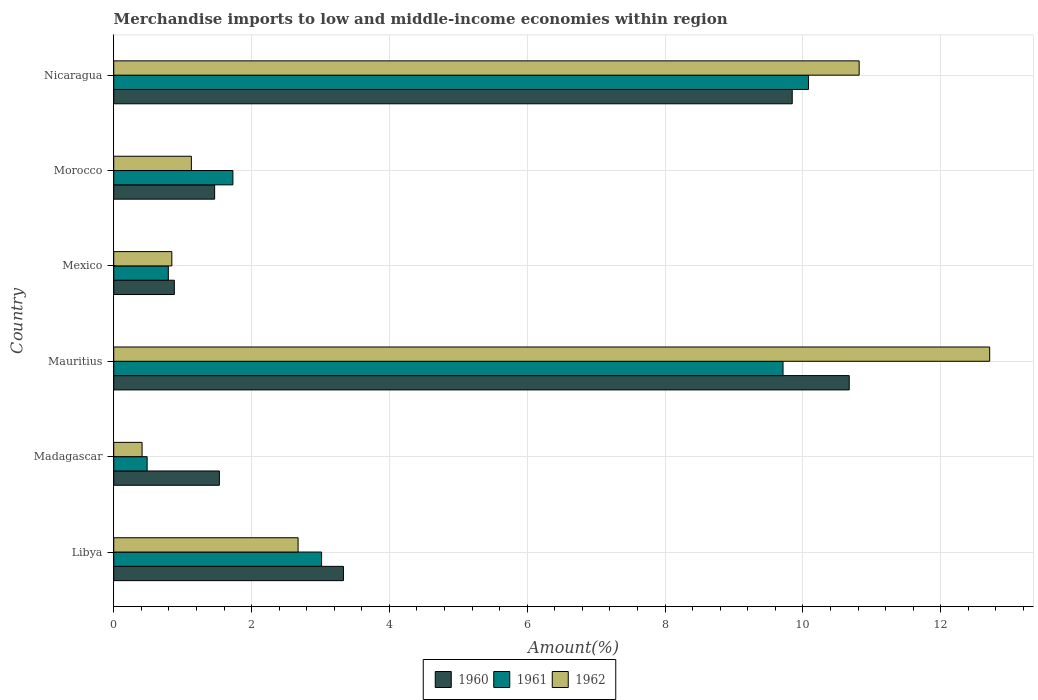How many different coloured bars are there?
Keep it short and to the point. 3. How many groups of bars are there?
Provide a succinct answer. 6. Are the number of bars per tick equal to the number of legend labels?
Provide a short and direct response. Yes. How many bars are there on the 5th tick from the bottom?
Offer a very short reply. 3. In how many cases, is the number of bars for a given country not equal to the number of legend labels?
Your response must be concise. 0. What is the percentage of amount earned from merchandise imports in 1961 in Libya?
Offer a very short reply. 3.02. Across all countries, what is the maximum percentage of amount earned from merchandise imports in 1960?
Provide a short and direct response. 10.67. Across all countries, what is the minimum percentage of amount earned from merchandise imports in 1961?
Ensure brevity in your answer.  0.48. In which country was the percentage of amount earned from merchandise imports in 1961 maximum?
Your answer should be very brief. Nicaragua. In which country was the percentage of amount earned from merchandise imports in 1961 minimum?
Make the answer very short. Madagascar. What is the total percentage of amount earned from merchandise imports in 1962 in the graph?
Your answer should be compact. 28.58. What is the difference between the percentage of amount earned from merchandise imports in 1960 in Mexico and that in Morocco?
Your answer should be compact. -0.59. What is the difference between the percentage of amount earned from merchandise imports in 1960 in Mauritius and the percentage of amount earned from merchandise imports in 1962 in Libya?
Keep it short and to the point. 8. What is the average percentage of amount earned from merchandise imports in 1961 per country?
Provide a succinct answer. 4.3. What is the difference between the percentage of amount earned from merchandise imports in 1960 and percentage of amount earned from merchandise imports in 1962 in Mauritius?
Provide a succinct answer. -2.04. What is the ratio of the percentage of amount earned from merchandise imports in 1960 in Mauritius to that in Morocco?
Ensure brevity in your answer.  7.29. Is the percentage of amount earned from merchandise imports in 1961 in Madagascar less than that in Mauritius?
Provide a succinct answer. Yes. What is the difference between the highest and the second highest percentage of amount earned from merchandise imports in 1962?
Provide a succinct answer. 1.89. What is the difference between the highest and the lowest percentage of amount earned from merchandise imports in 1962?
Offer a very short reply. 12.3. In how many countries, is the percentage of amount earned from merchandise imports in 1962 greater than the average percentage of amount earned from merchandise imports in 1962 taken over all countries?
Keep it short and to the point. 2. What does the 1st bar from the top in Mexico represents?
Keep it short and to the point. 1962. Are all the bars in the graph horizontal?
Ensure brevity in your answer.  Yes. How many countries are there in the graph?
Provide a short and direct response. 6. What is the difference between two consecutive major ticks on the X-axis?
Make the answer very short. 2. Are the values on the major ticks of X-axis written in scientific E-notation?
Your answer should be very brief. No. Does the graph contain any zero values?
Your answer should be very brief. No. Where does the legend appear in the graph?
Your answer should be very brief. Bottom center. How many legend labels are there?
Your answer should be compact. 3. How are the legend labels stacked?
Provide a short and direct response. Horizontal. What is the title of the graph?
Ensure brevity in your answer.  Merchandise imports to low and middle-income economies within region. Does "1970" appear as one of the legend labels in the graph?
Provide a succinct answer. No. What is the label or title of the X-axis?
Your response must be concise. Amount(%). What is the Amount(%) in 1960 in Libya?
Offer a terse response. 3.33. What is the Amount(%) of 1961 in Libya?
Provide a succinct answer. 3.02. What is the Amount(%) of 1962 in Libya?
Your answer should be compact. 2.68. What is the Amount(%) of 1960 in Madagascar?
Ensure brevity in your answer.  1.53. What is the Amount(%) in 1961 in Madagascar?
Your response must be concise. 0.48. What is the Amount(%) of 1962 in Madagascar?
Ensure brevity in your answer.  0.41. What is the Amount(%) of 1960 in Mauritius?
Offer a terse response. 10.67. What is the Amount(%) in 1961 in Mauritius?
Ensure brevity in your answer.  9.71. What is the Amount(%) of 1962 in Mauritius?
Ensure brevity in your answer.  12.71. What is the Amount(%) in 1960 in Mexico?
Provide a short and direct response. 0.88. What is the Amount(%) of 1961 in Mexico?
Offer a terse response. 0.79. What is the Amount(%) in 1962 in Mexico?
Offer a terse response. 0.84. What is the Amount(%) in 1960 in Morocco?
Your answer should be very brief. 1.46. What is the Amount(%) of 1961 in Morocco?
Your answer should be compact. 1.73. What is the Amount(%) in 1962 in Morocco?
Offer a terse response. 1.13. What is the Amount(%) of 1960 in Nicaragua?
Ensure brevity in your answer.  9.85. What is the Amount(%) in 1961 in Nicaragua?
Provide a short and direct response. 10.08. What is the Amount(%) of 1962 in Nicaragua?
Your response must be concise. 10.82. Across all countries, what is the maximum Amount(%) in 1960?
Provide a short and direct response. 10.67. Across all countries, what is the maximum Amount(%) in 1961?
Your response must be concise. 10.08. Across all countries, what is the maximum Amount(%) of 1962?
Ensure brevity in your answer.  12.71. Across all countries, what is the minimum Amount(%) in 1960?
Offer a very short reply. 0.88. Across all countries, what is the minimum Amount(%) in 1961?
Give a very brief answer. 0.48. Across all countries, what is the minimum Amount(%) in 1962?
Make the answer very short. 0.41. What is the total Amount(%) in 1960 in the graph?
Offer a very short reply. 27.73. What is the total Amount(%) of 1961 in the graph?
Keep it short and to the point. 25.81. What is the total Amount(%) of 1962 in the graph?
Keep it short and to the point. 28.58. What is the difference between the Amount(%) of 1960 in Libya and that in Madagascar?
Offer a very short reply. 1.8. What is the difference between the Amount(%) in 1961 in Libya and that in Madagascar?
Your answer should be very brief. 2.53. What is the difference between the Amount(%) in 1962 in Libya and that in Madagascar?
Provide a succinct answer. 2.26. What is the difference between the Amount(%) in 1960 in Libya and that in Mauritius?
Give a very brief answer. -7.34. What is the difference between the Amount(%) in 1961 in Libya and that in Mauritius?
Your answer should be very brief. -6.7. What is the difference between the Amount(%) in 1962 in Libya and that in Mauritius?
Give a very brief answer. -10.04. What is the difference between the Amount(%) in 1960 in Libya and that in Mexico?
Offer a very short reply. 2.45. What is the difference between the Amount(%) in 1961 in Libya and that in Mexico?
Offer a very short reply. 2.22. What is the difference between the Amount(%) of 1962 in Libya and that in Mexico?
Ensure brevity in your answer.  1.83. What is the difference between the Amount(%) in 1960 in Libya and that in Morocco?
Keep it short and to the point. 1.87. What is the difference between the Amount(%) in 1961 in Libya and that in Morocco?
Offer a very short reply. 1.29. What is the difference between the Amount(%) in 1962 in Libya and that in Morocco?
Keep it short and to the point. 1.55. What is the difference between the Amount(%) of 1960 in Libya and that in Nicaragua?
Provide a succinct answer. -6.51. What is the difference between the Amount(%) in 1961 in Libya and that in Nicaragua?
Ensure brevity in your answer.  -7.06. What is the difference between the Amount(%) of 1962 in Libya and that in Nicaragua?
Make the answer very short. -8.14. What is the difference between the Amount(%) of 1960 in Madagascar and that in Mauritius?
Your response must be concise. -9.14. What is the difference between the Amount(%) of 1961 in Madagascar and that in Mauritius?
Your answer should be very brief. -9.23. What is the difference between the Amount(%) in 1962 in Madagascar and that in Mauritius?
Provide a short and direct response. -12.3. What is the difference between the Amount(%) in 1960 in Madagascar and that in Mexico?
Provide a short and direct response. 0.65. What is the difference between the Amount(%) of 1961 in Madagascar and that in Mexico?
Ensure brevity in your answer.  -0.31. What is the difference between the Amount(%) of 1962 in Madagascar and that in Mexico?
Your response must be concise. -0.43. What is the difference between the Amount(%) of 1960 in Madagascar and that in Morocco?
Your response must be concise. 0.07. What is the difference between the Amount(%) of 1961 in Madagascar and that in Morocco?
Your response must be concise. -1.24. What is the difference between the Amount(%) in 1962 in Madagascar and that in Morocco?
Provide a succinct answer. -0.72. What is the difference between the Amount(%) in 1960 in Madagascar and that in Nicaragua?
Give a very brief answer. -8.31. What is the difference between the Amount(%) of 1961 in Madagascar and that in Nicaragua?
Your answer should be compact. -9.6. What is the difference between the Amount(%) of 1962 in Madagascar and that in Nicaragua?
Keep it short and to the point. -10.41. What is the difference between the Amount(%) of 1960 in Mauritius and that in Mexico?
Offer a terse response. 9.79. What is the difference between the Amount(%) of 1961 in Mauritius and that in Mexico?
Ensure brevity in your answer.  8.92. What is the difference between the Amount(%) in 1962 in Mauritius and that in Mexico?
Give a very brief answer. 11.87. What is the difference between the Amount(%) of 1960 in Mauritius and that in Morocco?
Offer a very short reply. 9.21. What is the difference between the Amount(%) of 1961 in Mauritius and that in Morocco?
Keep it short and to the point. 7.98. What is the difference between the Amount(%) in 1962 in Mauritius and that in Morocco?
Provide a short and direct response. 11.58. What is the difference between the Amount(%) of 1960 in Mauritius and that in Nicaragua?
Offer a terse response. 0.83. What is the difference between the Amount(%) in 1961 in Mauritius and that in Nicaragua?
Provide a succinct answer. -0.37. What is the difference between the Amount(%) in 1962 in Mauritius and that in Nicaragua?
Your answer should be very brief. 1.89. What is the difference between the Amount(%) in 1960 in Mexico and that in Morocco?
Keep it short and to the point. -0.59. What is the difference between the Amount(%) in 1961 in Mexico and that in Morocco?
Offer a terse response. -0.94. What is the difference between the Amount(%) of 1962 in Mexico and that in Morocco?
Make the answer very short. -0.28. What is the difference between the Amount(%) of 1960 in Mexico and that in Nicaragua?
Offer a terse response. -8.97. What is the difference between the Amount(%) in 1961 in Mexico and that in Nicaragua?
Your answer should be compact. -9.29. What is the difference between the Amount(%) of 1962 in Mexico and that in Nicaragua?
Provide a succinct answer. -9.97. What is the difference between the Amount(%) of 1960 in Morocco and that in Nicaragua?
Your answer should be compact. -8.38. What is the difference between the Amount(%) in 1961 in Morocco and that in Nicaragua?
Offer a terse response. -8.35. What is the difference between the Amount(%) in 1962 in Morocco and that in Nicaragua?
Provide a succinct answer. -9.69. What is the difference between the Amount(%) in 1960 in Libya and the Amount(%) in 1961 in Madagascar?
Make the answer very short. 2.85. What is the difference between the Amount(%) of 1960 in Libya and the Amount(%) of 1962 in Madagascar?
Offer a very short reply. 2.92. What is the difference between the Amount(%) in 1961 in Libya and the Amount(%) in 1962 in Madagascar?
Your response must be concise. 2.6. What is the difference between the Amount(%) of 1960 in Libya and the Amount(%) of 1961 in Mauritius?
Ensure brevity in your answer.  -6.38. What is the difference between the Amount(%) in 1960 in Libya and the Amount(%) in 1962 in Mauritius?
Provide a succinct answer. -9.38. What is the difference between the Amount(%) in 1961 in Libya and the Amount(%) in 1962 in Mauritius?
Keep it short and to the point. -9.69. What is the difference between the Amount(%) of 1960 in Libya and the Amount(%) of 1961 in Mexico?
Keep it short and to the point. 2.54. What is the difference between the Amount(%) of 1960 in Libya and the Amount(%) of 1962 in Mexico?
Your answer should be very brief. 2.49. What is the difference between the Amount(%) in 1961 in Libya and the Amount(%) in 1962 in Mexico?
Your answer should be compact. 2.17. What is the difference between the Amount(%) of 1960 in Libya and the Amount(%) of 1961 in Morocco?
Give a very brief answer. 1.6. What is the difference between the Amount(%) of 1960 in Libya and the Amount(%) of 1962 in Morocco?
Your answer should be very brief. 2.21. What is the difference between the Amount(%) in 1961 in Libya and the Amount(%) in 1962 in Morocco?
Offer a very short reply. 1.89. What is the difference between the Amount(%) of 1960 in Libya and the Amount(%) of 1961 in Nicaragua?
Provide a succinct answer. -6.75. What is the difference between the Amount(%) in 1960 in Libya and the Amount(%) in 1962 in Nicaragua?
Offer a very short reply. -7.48. What is the difference between the Amount(%) of 1961 in Libya and the Amount(%) of 1962 in Nicaragua?
Give a very brief answer. -7.8. What is the difference between the Amount(%) of 1960 in Madagascar and the Amount(%) of 1961 in Mauritius?
Your answer should be very brief. -8.18. What is the difference between the Amount(%) in 1960 in Madagascar and the Amount(%) in 1962 in Mauritius?
Keep it short and to the point. -11.18. What is the difference between the Amount(%) of 1961 in Madagascar and the Amount(%) of 1962 in Mauritius?
Your answer should be compact. -12.23. What is the difference between the Amount(%) of 1960 in Madagascar and the Amount(%) of 1961 in Mexico?
Offer a very short reply. 0.74. What is the difference between the Amount(%) of 1960 in Madagascar and the Amount(%) of 1962 in Mexico?
Offer a terse response. 0.69. What is the difference between the Amount(%) of 1961 in Madagascar and the Amount(%) of 1962 in Mexico?
Offer a terse response. -0.36. What is the difference between the Amount(%) of 1960 in Madagascar and the Amount(%) of 1961 in Morocco?
Provide a short and direct response. -0.2. What is the difference between the Amount(%) of 1960 in Madagascar and the Amount(%) of 1962 in Morocco?
Provide a short and direct response. 0.41. What is the difference between the Amount(%) of 1961 in Madagascar and the Amount(%) of 1962 in Morocco?
Make the answer very short. -0.64. What is the difference between the Amount(%) in 1960 in Madagascar and the Amount(%) in 1961 in Nicaragua?
Keep it short and to the point. -8.55. What is the difference between the Amount(%) of 1960 in Madagascar and the Amount(%) of 1962 in Nicaragua?
Your answer should be very brief. -9.28. What is the difference between the Amount(%) of 1961 in Madagascar and the Amount(%) of 1962 in Nicaragua?
Keep it short and to the point. -10.33. What is the difference between the Amount(%) of 1960 in Mauritius and the Amount(%) of 1961 in Mexico?
Your answer should be compact. 9.88. What is the difference between the Amount(%) of 1960 in Mauritius and the Amount(%) of 1962 in Mexico?
Ensure brevity in your answer.  9.83. What is the difference between the Amount(%) of 1961 in Mauritius and the Amount(%) of 1962 in Mexico?
Provide a succinct answer. 8.87. What is the difference between the Amount(%) in 1960 in Mauritius and the Amount(%) in 1961 in Morocco?
Your answer should be compact. 8.94. What is the difference between the Amount(%) in 1960 in Mauritius and the Amount(%) in 1962 in Morocco?
Provide a short and direct response. 9.55. What is the difference between the Amount(%) of 1961 in Mauritius and the Amount(%) of 1962 in Morocco?
Your response must be concise. 8.59. What is the difference between the Amount(%) of 1960 in Mauritius and the Amount(%) of 1961 in Nicaragua?
Give a very brief answer. 0.59. What is the difference between the Amount(%) of 1960 in Mauritius and the Amount(%) of 1962 in Nicaragua?
Give a very brief answer. -0.14. What is the difference between the Amount(%) in 1961 in Mauritius and the Amount(%) in 1962 in Nicaragua?
Offer a very short reply. -1.1. What is the difference between the Amount(%) of 1960 in Mexico and the Amount(%) of 1961 in Morocco?
Your answer should be compact. -0.85. What is the difference between the Amount(%) in 1960 in Mexico and the Amount(%) in 1962 in Morocco?
Your answer should be very brief. -0.25. What is the difference between the Amount(%) in 1961 in Mexico and the Amount(%) in 1962 in Morocco?
Your response must be concise. -0.33. What is the difference between the Amount(%) in 1960 in Mexico and the Amount(%) in 1961 in Nicaragua?
Offer a very short reply. -9.2. What is the difference between the Amount(%) of 1960 in Mexico and the Amount(%) of 1962 in Nicaragua?
Give a very brief answer. -9.94. What is the difference between the Amount(%) of 1961 in Mexico and the Amount(%) of 1962 in Nicaragua?
Ensure brevity in your answer.  -10.02. What is the difference between the Amount(%) in 1960 in Morocco and the Amount(%) in 1961 in Nicaragua?
Keep it short and to the point. -8.62. What is the difference between the Amount(%) of 1960 in Morocco and the Amount(%) of 1962 in Nicaragua?
Offer a very short reply. -9.35. What is the difference between the Amount(%) in 1961 in Morocco and the Amount(%) in 1962 in Nicaragua?
Provide a succinct answer. -9.09. What is the average Amount(%) of 1960 per country?
Offer a terse response. 4.62. What is the average Amount(%) in 1961 per country?
Your response must be concise. 4.3. What is the average Amount(%) of 1962 per country?
Give a very brief answer. 4.76. What is the difference between the Amount(%) in 1960 and Amount(%) in 1961 in Libya?
Provide a short and direct response. 0.32. What is the difference between the Amount(%) of 1960 and Amount(%) of 1962 in Libya?
Keep it short and to the point. 0.66. What is the difference between the Amount(%) of 1961 and Amount(%) of 1962 in Libya?
Your response must be concise. 0.34. What is the difference between the Amount(%) in 1960 and Amount(%) in 1961 in Madagascar?
Make the answer very short. 1.05. What is the difference between the Amount(%) of 1960 and Amount(%) of 1962 in Madagascar?
Provide a short and direct response. 1.12. What is the difference between the Amount(%) in 1961 and Amount(%) in 1962 in Madagascar?
Your answer should be compact. 0.07. What is the difference between the Amount(%) in 1960 and Amount(%) in 1961 in Mauritius?
Ensure brevity in your answer.  0.96. What is the difference between the Amount(%) in 1960 and Amount(%) in 1962 in Mauritius?
Keep it short and to the point. -2.04. What is the difference between the Amount(%) in 1961 and Amount(%) in 1962 in Mauritius?
Your answer should be very brief. -3. What is the difference between the Amount(%) of 1960 and Amount(%) of 1961 in Mexico?
Give a very brief answer. 0.09. What is the difference between the Amount(%) of 1960 and Amount(%) of 1962 in Mexico?
Keep it short and to the point. 0.04. What is the difference between the Amount(%) in 1961 and Amount(%) in 1962 in Mexico?
Keep it short and to the point. -0.05. What is the difference between the Amount(%) of 1960 and Amount(%) of 1961 in Morocco?
Your response must be concise. -0.27. What is the difference between the Amount(%) in 1960 and Amount(%) in 1962 in Morocco?
Your answer should be very brief. 0.34. What is the difference between the Amount(%) in 1961 and Amount(%) in 1962 in Morocco?
Your answer should be very brief. 0.6. What is the difference between the Amount(%) in 1960 and Amount(%) in 1961 in Nicaragua?
Give a very brief answer. -0.24. What is the difference between the Amount(%) of 1960 and Amount(%) of 1962 in Nicaragua?
Your answer should be compact. -0.97. What is the difference between the Amount(%) in 1961 and Amount(%) in 1962 in Nicaragua?
Ensure brevity in your answer.  -0.74. What is the ratio of the Amount(%) in 1960 in Libya to that in Madagascar?
Provide a succinct answer. 2.17. What is the ratio of the Amount(%) in 1961 in Libya to that in Madagascar?
Your answer should be compact. 6.23. What is the ratio of the Amount(%) in 1962 in Libya to that in Madagascar?
Your answer should be compact. 6.51. What is the ratio of the Amount(%) in 1960 in Libya to that in Mauritius?
Provide a succinct answer. 0.31. What is the ratio of the Amount(%) of 1961 in Libya to that in Mauritius?
Provide a short and direct response. 0.31. What is the ratio of the Amount(%) of 1962 in Libya to that in Mauritius?
Offer a very short reply. 0.21. What is the ratio of the Amount(%) of 1960 in Libya to that in Mexico?
Make the answer very short. 3.79. What is the ratio of the Amount(%) of 1961 in Libya to that in Mexico?
Your answer should be very brief. 3.81. What is the ratio of the Amount(%) in 1962 in Libya to that in Mexico?
Ensure brevity in your answer.  3.17. What is the ratio of the Amount(%) in 1960 in Libya to that in Morocco?
Your answer should be very brief. 2.28. What is the ratio of the Amount(%) of 1961 in Libya to that in Morocco?
Your response must be concise. 1.74. What is the ratio of the Amount(%) in 1962 in Libya to that in Morocco?
Give a very brief answer. 2.37. What is the ratio of the Amount(%) of 1960 in Libya to that in Nicaragua?
Your answer should be very brief. 0.34. What is the ratio of the Amount(%) in 1961 in Libya to that in Nicaragua?
Make the answer very short. 0.3. What is the ratio of the Amount(%) in 1962 in Libya to that in Nicaragua?
Keep it short and to the point. 0.25. What is the ratio of the Amount(%) in 1960 in Madagascar to that in Mauritius?
Give a very brief answer. 0.14. What is the ratio of the Amount(%) of 1961 in Madagascar to that in Mauritius?
Provide a succinct answer. 0.05. What is the ratio of the Amount(%) in 1962 in Madagascar to that in Mauritius?
Your answer should be compact. 0.03. What is the ratio of the Amount(%) of 1960 in Madagascar to that in Mexico?
Your answer should be compact. 1.74. What is the ratio of the Amount(%) in 1961 in Madagascar to that in Mexico?
Provide a short and direct response. 0.61. What is the ratio of the Amount(%) of 1962 in Madagascar to that in Mexico?
Offer a very short reply. 0.49. What is the ratio of the Amount(%) of 1960 in Madagascar to that in Morocco?
Offer a very short reply. 1.05. What is the ratio of the Amount(%) of 1961 in Madagascar to that in Morocco?
Offer a terse response. 0.28. What is the ratio of the Amount(%) of 1962 in Madagascar to that in Morocco?
Offer a very short reply. 0.36. What is the ratio of the Amount(%) of 1960 in Madagascar to that in Nicaragua?
Offer a very short reply. 0.16. What is the ratio of the Amount(%) in 1961 in Madagascar to that in Nicaragua?
Your response must be concise. 0.05. What is the ratio of the Amount(%) in 1962 in Madagascar to that in Nicaragua?
Give a very brief answer. 0.04. What is the ratio of the Amount(%) in 1960 in Mauritius to that in Mexico?
Give a very brief answer. 12.14. What is the ratio of the Amount(%) of 1961 in Mauritius to that in Mexico?
Ensure brevity in your answer.  12.26. What is the ratio of the Amount(%) of 1962 in Mauritius to that in Mexico?
Offer a very short reply. 15.08. What is the ratio of the Amount(%) of 1960 in Mauritius to that in Morocco?
Provide a succinct answer. 7.29. What is the ratio of the Amount(%) in 1961 in Mauritius to that in Morocco?
Your response must be concise. 5.62. What is the ratio of the Amount(%) of 1962 in Mauritius to that in Morocco?
Keep it short and to the point. 11.28. What is the ratio of the Amount(%) in 1960 in Mauritius to that in Nicaragua?
Keep it short and to the point. 1.08. What is the ratio of the Amount(%) in 1961 in Mauritius to that in Nicaragua?
Provide a short and direct response. 0.96. What is the ratio of the Amount(%) in 1962 in Mauritius to that in Nicaragua?
Give a very brief answer. 1.18. What is the ratio of the Amount(%) in 1960 in Mexico to that in Morocco?
Make the answer very short. 0.6. What is the ratio of the Amount(%) of 1961 in Mexico to that in Morocco?
Keep it short and to the point. 0.46. What is the ratio of the Amount(%) in 1962 in Mexico to that in Morocco?
Your answer should be compact. 0.75. What is the ratio of the Amount(%) of 1960 in Mexico to that in Nicaragua?
Your answer should be compact. 0.09. What is the ratio of the Amount(%) in 1961 in Mexico to that in Nicaragua?
Keep it short and to the point. 0.08. What is the ratio of the Amount(%) of 1962 in Mexico to that in Nicaragua?
Ensure brevity in your answer.  0.08. What is the ratio of the Amount(%) of 1960 in Morocco to that in Nicaragua?
Keep it short and to the point. 0.15. What is the ratio of the Amount(%) of 1961 in Morocco to that in Nicaragua?
Offer a terse response. 0.17. What is the ratio of the Amount(%) in 1962 in Morocco to that in Nicaragua?
Provide a succinct answer. 0.1. What is the difference between the highest and the second highest Amount(%) in 1960?
Ensure brevity in your answer.  0.83. What is the difference between the highest and the second highest Amount(%) in 1961?
Offer a terse response. 0.37. What is the difference between the highest and the second highest Amount(%) in 1962?
Your response must be concise. 1.89. What is the difference between the highest and the lowest Amount(%) in 1960?
Ensure brevity in your answer.  9.79. What is the difference between the highest and the lowest Amount(%) of 1961?
Make the answer very short. 9.6. What is the difference between the highest and the lowest Amount(%) of 1962?
Give a very brief answer. 12.3. 